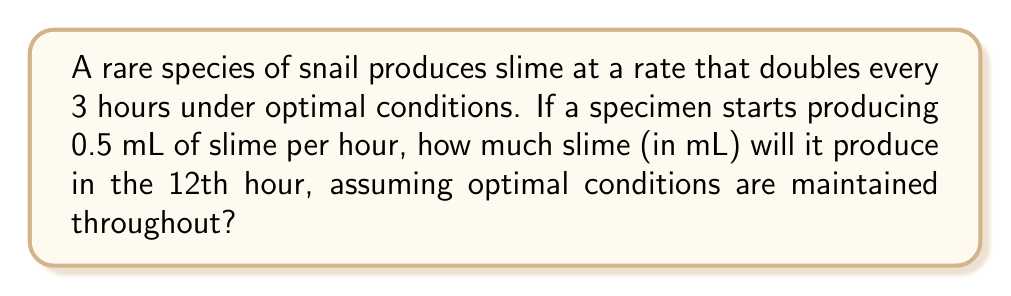What is the answer to this math problem? Let's approach this step-by-step:

1) First, we need to determine how many times the slime production rate doubles in 12 hours:
   $\frac{12 \text{ hours}}{3 \text{ hours per doubling}} = 4 \text{ doublings}$

2) We can represent this mathematically as:
   $0.5 \text{ mL/hour} \times 2^4$

3) Let's calculate $2^4$:
   $2^4 = 2 \times 2 \times 2 \times 2 = 16$

4) Now, we multiply the initial rate by this factor:
   $0.5 \text{ mL/hour} \times 16 = 8 \text{ mL/hour}$

5) This means that in the 12th hour, the snail will be producing slime at a rate of 8 mL per hour.

6) Since we're asked about the production in the 12th hour specifically (not over 12 hours), this rate is our final answer.

The exponential growth can be represented by the formula:

$$\text{Rate}_t = \text{Rate}_0 \times 2^{\frac{t}{3}}$$

Where $\text{Rate}_t$ is the rate at time $t$ (in hours), and $\text{Rate}_0$ is the initial rate.
Answer: 8 mL 